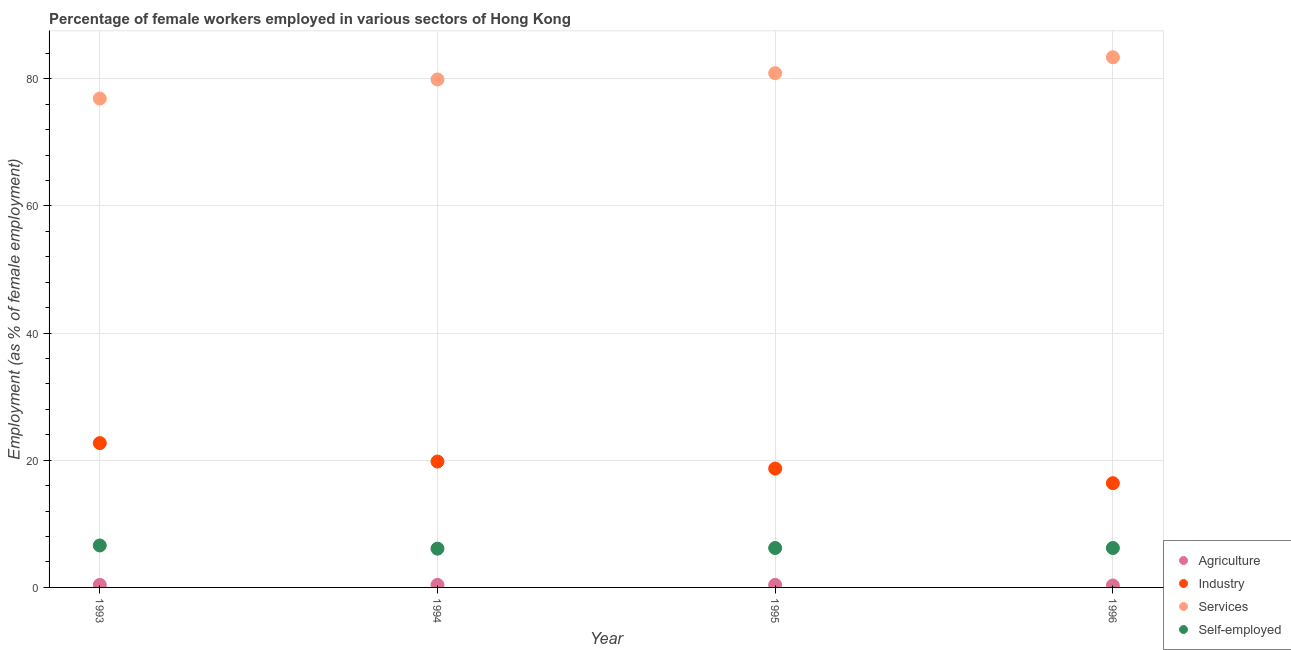What is the percentage of female workers in services in 1996?
Offer a terse response. 83.4. Across all years, what is the maximum percentage of female workers in industry?
Your response must be concise. 22.7. Across all years, what is the minimum percentage of female workers in services?
Offer a very short reply. 76.9. In which year was the percentage of female workers in services maximum?
Give a very brief answer. 1996. What is the total percentage of female workers in industry in the graph?
Make the answer very short. 77.6. What is the difference between the percentage of self employed female workers in 1993 and that in 1995?
Offer a very short reply. 0.4. What is the difference between the percentage of female workers in industry in 1993 and the percentage of female workers in services in 1995?
Make the answer very short. -58.2. What is the average percentage of female workers in agriculture per year?
Ensure brevity in your answer.  0.38. In the year 1995, what is the difference between the percentage of self employed female workers and percentage of female workers in industry?
Offer a very short reply. -12.5. In how many years, is the percentage of female workers in industry greater than 68 %?
Offer a very short reply. 0. What is the ratio of the percentage of female workers in services in 1993 to that in 1994?
Your response must be concise. 0.96. Is the difference between the percentage of self employed female workers in 1993 and 1995 greater than the difference between the percentage of female workers in services in 1993 and 1995?
Provide a short and direct response. Yes. What is the difference between the highest and the lowest percentage of female workers in industry?
Your answer should be compact. 6.3. In how many years, is the percentage of female workers in agriculture greater than the average percentage of female workers in agriculture taken over all years?
Ensure brevity in your answer.  3. Is it the case that in every year, the sum of the percentage of female workers in agriculture and percentage of female workers in industry is greater than the percentage of female workers in services?
Ensure brevity in your answer.  No. Is the percentage of self employed female workers strictly greater than the percentage of female workers in services over the years?
Offer a very short reply. No. How many dotlines are there?
Give a very brief answer. 4. How many years are there in the graph?
Offer a terse response. 4. What is the difference between two consecutive major ticks on the Y-axis?
Offer a very short reply. 20. Are the values on the major ticks of Y-axis written in scientific E-notation?
Your answer should be compact. No. Where does the legend appear in the graph?
Give a very brief answer. Bottom right. How many legend labels are there?
Offer a terse response. 4. What is the title of the graph?
Your response must be concise. Percentage of female workers employed in various sectors of Hong Kong. Does "Pre-primary schools" appear as one of the legend labels in the graph?
Ensure brevity in your answer.  No. What is the label or title of the X-axis?
Ensure brevity in your answer.  Year. What is the label or title of the Y-axis?
Give a very brief answer. Employment (as % of female employment). What is the Employment (as % of female employment) in Agriculture in 1993?
Provide a short and direct response. 0.4. What is the Employment (as % of female employment) in Industry in 1993?
Your answer should be very brief. 22.7. What is the Employment (as % of female employment) of Services in 1993?
Your response must be concise. 76.9. What is the Employment (as % of female employment) in Self-employed in 1993?
Offer a terse response. 6.6. What is the Employment (as % of female employment) of Agriculture in 1994?
Your response must be concise. 0.4. What is the Employment (as % of female employment) in Industry in 1994?
Your answer should be very brief. 19.8. What is the Employment (as % of female employment) of Services in 1994?
Keep it short and to the point. 79.9. What is the Employment (as % of female employment) in Self-employed in 1994?
Your answer should be compact. 6.1. What is the Employment (as % of female employment) in Agriculture in 1995?
Keep it short and to the point. 0.4. What is the Employment (as % of female employment) of Industry in 1995?
Keep it short and to the point. 18.7. What is the Employment (as % of female employment) of Services in 1995?
Offer a very short reply. 80.9. What is the Employment (as % of female employment) of Self-employed in 1995?
Give a very brief answer. 6.2. What is the Employment (as % of female employment) in Agriculture in 1996?
Provide a succinct answer. 0.3. What is the Employment (as % of female employment) in Industry in 1996?
Provide a short and direct response. 16.4. What is the Employment (as % of female employment) of Services in 1996?
Your answer should be very brief. 83.4. What is the Employment (as % of female employment) in Self-employed in 1996?
Your answer should be very brief. 6.2. Across all years, what is the maximum Employment (as % of female employment) in Agriculture?
Offer a terse response. 0.4. Across all years, what is the maximum Employment (as % of female employment) of Industry?
Offer a very short reply. 22.7. Across all years, what is the maximum Employment (as % of female employment) in Services?
Your response must be concise. 83.4. Across all years, what is the maximum Employment (as % of female employment) in Self-employed?
Make the answer very short. 6.6. Across all years, what is the minimum Employment (as % of female employment) in Agriculture?
Your answer should be very brief. 0.3. Across all years, what is the minimum Employment (as % of female employment) of Industry?
Your answer should be compact. 16.4. Across all years, what is the minimum Employment (as % of female employment) of Services?
Provide a short and direct response. 76.9. Across all years, what is the minimum Employment (as % of female employment) of Self-employed?
Your answer should be very brief. 6.1. What is the total Employment (as % of female employment) of Industry in the graph?
Offer a terse response. 77.6. What is the total Employment (as % of female employment) in Services in the graph?
Offer a terse response. 321.1. What is the total Employment (as % of female employment) in Self-employed in the graph?
Provide a short and direct response. 25.1. What is the difference between the Employment (as % of female employment) of Agriculture in 1993 and that in 1994?
Give a very brief answer. 0. What is the difference between the Employment (as % of female employment) in Services in 1993 and that in 1994?
Provide a succinct answer. -3. What is the difference between the Employment (as % of female employment) of Agriculture in 1993 and that in 1995?
Ensure brevity in your answer.  0. What is the difference between the Employment (as % of female employment) of Services in 1993 and that in 1996?
Offer a very short reply. -6.5. What is the difference between the Employment (as % of female employment) in Agriculture in 1994 and that in 1995?
Keep it short and to the point. 0. What is the difference between the Employment (as % of female employment) in Self-employed in 1994 and that in 1995?
Ensure brevity in your answer.  -0.1. What is the difference between the Employment (as % of female employment) of Agriculture in 1994 and that in 1996?
Provide a succinct answer. 0.1. What is the difference between the Employment (as % of female employment) of Industry in 1994 and that in 1996?
Give a very brief answer. 3.4. What is the difference between the Employment (as % of female employment) in Services in 1994 and that in 1996?
Your response must be concise. -3.5. What is the difference between the Employment (as % of female employment) in Self-employed in 1994 and that in 1996?
Provide a short and direct response. -0.1. What is the difference between the Employment (as % of female employment) of Industry in 1995 and that in 1996?
Your answer should be very brief. 2.3. What is the difference between the Employment (as % of female employment) in Services in 1995 and that in 1996?
Offer a terse response. -2.5. What is the difference between the Employment (as % of female employment) of Self-employed in 1995 and that in 1996?
Keep it short and to the point. 0. What is the difference between the Employment (as % of female employment) in Agriculture in 1993 and the Employment (as % of female employment) in Industry in 1994?
Offer a very short reply. -19.4. What is the difference between the Employment (as % of female employment) in Agriculture in 1993 and the Employment (as % of female employment) in Services in 1994?
Offer a very short reply. -79.5. What is the difference between the Employment (as % of female employment) of Industry in 1993 and the Employment (as % of female employment) of Services in 1994?
Provide a short and direct response. -57.2. What is the difference between the Employment (as % of female employment) in Services in 1993 and the Employment (as % of female employment) in Self-employed in 1994?
Your response must be concise. 70.8. What is the difference between the Employment (as % of female employment) of Agriculture in 1993 and the Employment (as % of female employment) of Industry in 1995?
Your answer should be compact. -18.3. What is the difference between the Employment (as % of female employment) in Agriculture in 1993 and the Employment (as % of female employment) in Services in 1995?
Make the answer very short. -80.5. What is the difference between the Employment (as % of female employment) in Agriculture in 1993 and the Employment (as % of female employment) in Self-employed in 1995?
Offer a terse response. -5.8. What is the difference between the Employment (as % of female employment) in Industry in 1993 and the Employment (as % of female employment) in Services in 1995?
Offer a terse response. -58.2. What is the difference between the Employment (as % of female employment) of Industry in 1993 and the Employment (as % of female employment) of Self-employed in 1995?
Make the answer very short. 16.5. What is the difference between the Employment (as % of female employment) in Services in 1993 and the Employment (as % of female employment) in Self-employed in 1995?
Keep it short and to the point. 70.7. What is the difference between the Employment (as % of female employment) of Agriculture in 1993 and the Employment (as % of female employment) of Industry in 1996?
Provide a succinct answer. -16. What is the difference between the Employment (as % of female employment) in Agriculture in 1993 and the Employment (as % of female employment) in Services in 1996?
Provide a succinct answer. -83. What is the difference between the Employment (as % of female employment) of Agriculture in 1993 and the Employment (as % of female employment) of Self-employed in 1996?
Make the answer very short. -5.8. What is the difference between the Employment (as % of female employment) in Industry in 1993 and the Employment (as % of female employment) in Services in 1996?
Your answer should be compact. -60.7. What is the difference between the Employment (as % of female employment) of Services in 1993 and the Employment (as % of female employment) of Self-employed in 1996?
Your answer should be very brief. 70.7. What is the difference between the Employment (as % of female employment) of Agriculture in 1994 and the Employment (as % of female employment) of Industry in 1995?
Offer a very short reply. -18.3. What is the difference between the Employment (as % of female employment) in Agriculture in 1994 and the Employment (as % of female employment) in Services in 1995?
Provide a succinct answer. -80.5. What is the difference between the Employment (as % of female employment) of Agriculture in 1994 and the Employment (as % of female employment) of Self-employed in 1995?
Offer a very short reply. -5.8. What is the difference between the Employment (as % of female employment) in Industry in 1994 and the Employment (as % of female employment) in Services in 1995?
Provide a succinct answer. -61.1. What is the difference between the Employment (as % of female employment) of Industry in 1994 and the Employment (as % of female employment) of Self-employed in 1995?
Provide a short and direct response. 13.6. What is the difference between the Employment (as % of female employment) of Services in 1994 and the Employment (as % of female employment) of Self-employed in 1995?
Provide a succinct answer. 73.7. What is the difference between the Employment (as % of female employment) in Agriculture in 1994 and the Employment (as % of female employment) in Industry in 1996?
Provide a succinct answer. -16. What is the difference between the Employment (as % of female employment) of Agriculture in 1994 and the Employment (as % of female employment) of Services in 1996?
Ensure brevity in your answer.  -83. What is the difference between the Employment (as % of female employment) in Industry in 1994 and the Employment (as % of female employment) in Services in 1996?
Your response must be concise. -63.6. What is the difference between the Employment (as % of female employment) of Services in 1994 and the Employment (as % of female employment) of Self-employed in 1996?
Your response must be concise. 73.7. What is the difference between the Employment (as % of female employment) in Agriculture in 1995 and the Employment (as % of female employment) in Industry in 1996?
Provide a succinct answer. -16. What is the difference between the Employment (as % of female employment) of Agriculture in 1995 and the Employment (as % of female employment) of Services in 1996?
Your answer should be very brief. -83. What is the difference between the Employment (as % of female employment) in Industry in 1995 and the Employment (as % of female employment) in Services in 1996?
Make the answer very short. -64.7. What is the difference between the Employment (as % of female employment) in Services in 1995 and the Employment (as % of female employment) in Self-employed in 1996?
Your response must be concise. 74.7. What is the average Employment (as % of female employment) of Agriculture per year?
Make the answer very short. 0.38. What is the average Employment (as % of female employment) in Industry per year?
Provide a short and direct response. 19.4. What is the average Employment (as % of female employment) of Services per year?
Your answer should be very brief. 80.28. What is the average Employment (as % of female employment) in Self-employed per year?
Offer a terse response. 6.28. In the year 1993, what is the difference between the Employment (as % of female employment) of Agriculture and Employment (as % of female employment) of Industry?
Your response must be concise. -22.3. In the year 1993, what is the difference between the Employment (as % of female employment) of Agriculture and Employment (as % of female employment) of Services?
Your answer should be very brief. -76.5. In the year 1993, what is the difference between the Employment (as % of female employment) in Agriculture and Employment (as % of female employment) in Self-employed?
Your response must be concise. -6.2. In the year 1993, what is the difference between the Employment (as % of female employment) in Industry and Employment (as % of female employment) in Services?
Your answer should be very brief. -54.2. In the year 1993, what is the difference between the Employment (as % of female employment) of Industry and Employment (as % of female employment) of Self-employed?
Offer a very short reply. 16.1. In the year 1993, what is the difference between the Employment (as % of female employment) of Services and Employment (as % of female employment) of Self-employed?
Your response must be concise. 70.3. In the year 1994, what is the difference between the Employment (as % of female employment) of Agriculture and Employment (as % of female employment) of Industry?
Offer a very short reply. -19.4. In the year 1994, what is the difference between the Employment (as % of female employment) of Agriculture and Employment (as % of female employment) of Services?
Your answer should be very brief. -79.5. In the year 1994, what is the difference between the Employment (as % of female employment) in Industry and Employment (as % of female employment) in Services?
Give a very brief answer. -60.1. In the year 1994, what is the difference between the Employment (as % of female employment) of Industry and Employment (as % of female employment) of Self-employed?
Make the answer very short. 13.7. In the year 1994, what is the difference between the Employment (as % of female employment) in Services and Employment (as % of female employment) in Self-employed?
Give a very brief answer. 73.8. In the year 1995, what is the difference between the Employment (as % of female employment) in Agriculture and Employment (as % of female employment) in Industry?
Keep it short and to the point. -18.3. In the year 1995, what is the difference between the Employment (as % of female employment) in Agriculture and Employment (as % of female employment) in Services?
Ensure brevity in your answer.  -80.5. In the year 1995, what is the difference between the Employment (as % of female employment) in Agriculture and Employment (as % of female employment) in Self-employed?
Keep it short and to the point. -5.8. In the year 1995, what is the difference between the Employment (as % of female employment) in Industry and Employment (as % of female employment) in Services?
Provide a succinct answer. -62.2. In the year 1995, what is the difference between the Employment (as % of female employment) in Services and Employment (as % of female employment) in Self-employed?
Offer a very short reply. 74.7. In the year 1996, what is the difference between the Employment (as % of female employment) of Agriculture and Employment (as % of female employment) of Industry?
Give a very brief answer. -16.1. In the year 1996, what is the difference between the Employment (as % of female employment) in Agriculture and Employment (as % of female employment) in Services?
Offer a terse response. -83.1. In the year 1996, what is the difference between the Employment (as % of female employment) of Agriculture and Employment (as % of female employment) of Self-employed?
Keep it short and to the point. -5.9. In the year 1996, what is the difference between the Employment (as % of female employment) in Industry and Employment (as % of female employment) in Services?
Provide a succinct answer. -67. In the year 1996, what is the difference between the Employment (as % of female employment) in Services and Employment (as % of female employment) in Self-employed?
Offer a terse response. 77.2. What is the ratio of the Employment (as % of female employment) of Agriculture in 1993 to that in 1994?
Provide a short and direct response. 1. What is the ratio of the Employment (as % of female employment) in Industry in 1993 to that in 1994?
Your answer should be very brief. 1.15. What is the ratio of the Employment (as % of female employment) in Services in 1993 to that in 1994?
Offer a terse response. 0.96. What is the ratio of the Employment (as % of female employment) in Self-employed in 1993 to that in 1994?
Your response must be concise. 1.08. What is the ratio of the Employment (as % of female employment) of Industry in 1993 to that in 1995?
Give a very brief answer. 1.21. What is the ratio of the Employment (as % of female employment) in Services in 1993 to that in 1995?
Offer a terse response. 0.95. What is the ratio of the Employment (as % of female employment) of Self-employed in 1993 to that in 1995?
Your answer should be compact. 1.06. What is the ratio of the Employment (as % of female employment) of Industry in 1993 to that in 1996?
Your answer should be very brief. 1.38. What is the ratio of the Employment (as % of female employment) of Services in 1993 to that in 1996?
Your answer should be very brief. 0.92. What is the ratio of the Employment (as % of female employment) in Self-employed in 1993 to that in 1996?
Your response must be concise. 1.06. What is the ratio of the Employment (as % of female employment) of Agriculture in 1994 to that in 1995?
Ensure brevity in your answer.  1. What is the ratio of the Employment (as % of female employment) of Industry in 1994 to that in 1995?
Your response must be concise. 1.06. What is the ratio of the Employment (as % of female employment) of Services in 1994 to that in 1995?
Your answer should be very brief. 0.99. What is the ratio of the Employment (as % of female employment) in Self-employed in 1994 to that in 1995?
Offer a terse response. 0.98. What is the ratio of the Employment (as % of female employment) of Industry in 1994 to that in 1996?
Keep it short and to the point. 1.21. What is the ratio of the Employment (as % of female employment) in Services in 1994 to that in 1996?
Provide a short and direct response. 0.96. What is the ratio of the Employment (as % of female employment) of Self-employed in 1994 to that in 1996?
Your answer should be compact. 0.98. What is the ratio of the Employment (as % of female employment) of Agriculture in 1995 to that in 1996?
Give a very brief answer. 1.33. What is the ratio of the Employment (as % of female employment) in Industry in 1995 to that in 1996?
Make the answer very short. 1.14. What is the ratio of the Employment (as % of female employment) in Services in 1995 to that in 1996?
Your answer should be very brief. 0.97. What is the ratio of the Employment (as % of female employment) of Self-employed in 1995 to that in 1996?
Keep it short and to the point. 1. What is the difference between the highest and the second highest Employment (as % of female employment) in Agriculture?
Keep it short and to the point. 0. What is the difference between the highest and the second highest Employment (as % of female employment) in Services?
Ensure brevity in your answer.  2.5. What is the difference between the highest and the second highest Employment (as % of female employment) of Self-employed?
Ensure brevity in your answer.  0.4. What is the difference between the highest and the lowest Employment (as % of female employment) of Agriculture?
Give a very brief answer. 0.1. What is the difference between the highest and the lowest Employment (as % of female employment) of Services?
Provide a short and direct response. 6.5. 